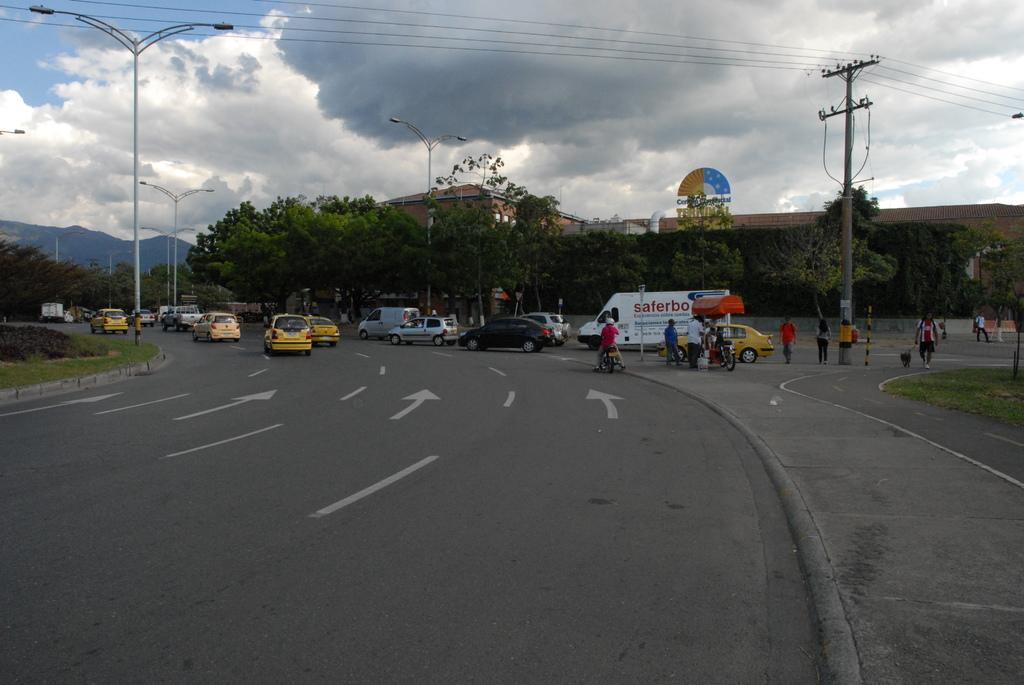What types of objects can be seen in the image? There are vehicles, poles, trees, mountains, buildings, and people walking on roads in the image. What is the environment like in the image? The image shows roads, trees, mountains, and buildings, suggesting an urban or suburban setting. What can be seen in the sky in the image? The sky is visible in the background of the image, and clouds are present. What type of calendar is hanging on the pole in the image? There is no calendar present in the image; only vehicles, poles, trees, mountains, buildings, people walking on roads, and the sky with clouds are visible. Can you tell me how many socks are visible on the people walking in the image? There is no mention of socks in the image; people walking on roads are visible, but their clothing is not described in detail. 